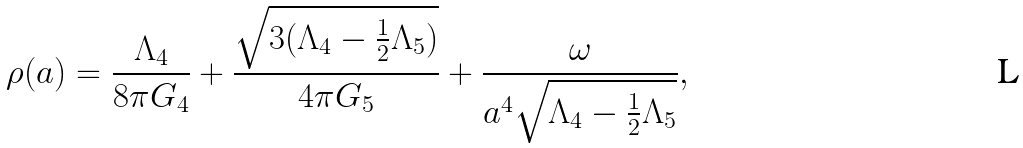Convert formula to latex. <formula><loc_0><loc_0><loc_500><loc_500>\rho ( a ) = \frac { \Lambda _ { 4 } } { 8 \pi G _ { 4 } } + \frac { \sqrt { 3 ( \Lambda _ { 4 } - \frac { 1 } { 2 } \Lambda _ { 5 } ) } } { 4 \pi G _ { 5 } } + \frac { \omega } { a ^ { 4 } \sqrt { \Lambda _ { 4 } - \frac { 1 } { 2 } \Lambda _ { 5 } } } ,</formula> 